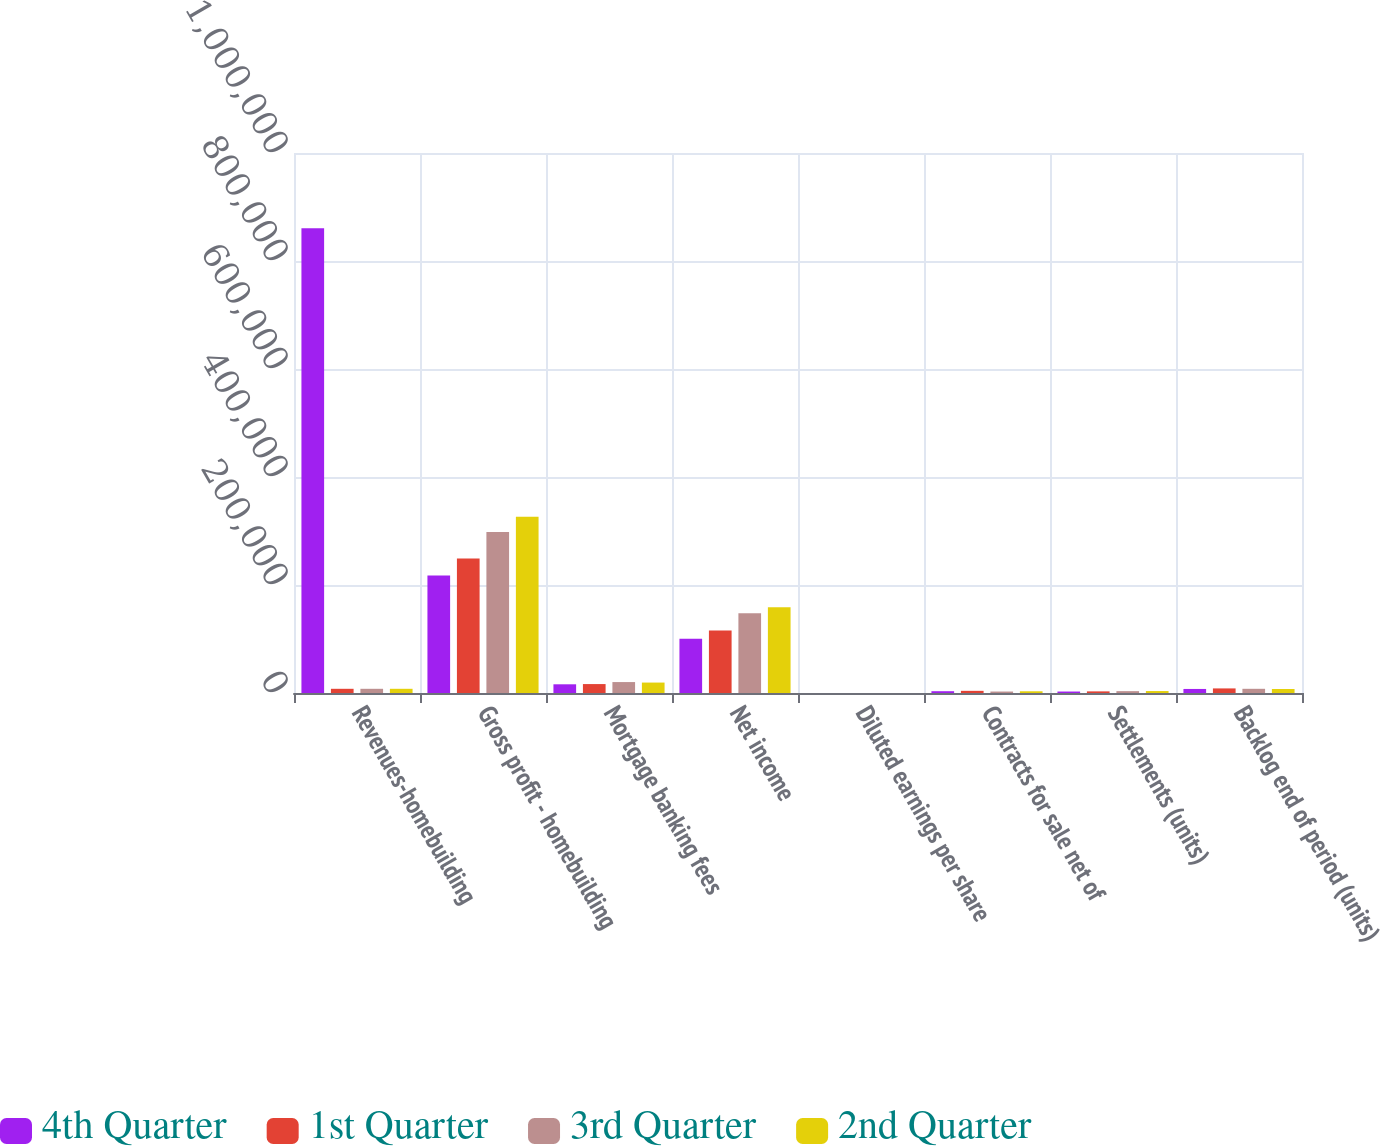Convert chart. <chart><loc_0><loc_0><loc_500><loc_500><stacked_bar_chart><ecel><fcel>Revenues-homebuilding<fcel>Gross profit - homebuilding<fcel>Mortgage banking fees<fcel>Net income<fcel>Diluted earnings per share<fcel>Contracts for sale net of<fcel>Settlements (units)<fcel>Backlog end of period (units)<nl><fcel>4th Quarter<fcel>860685<fcel>217674<fcel>16108<fcel>100617<fcel>12.58<fcel>3318<fcel>2709<fcel>7499<nl><fcel>1st Quarter<fcel>7775<fcel>248855<fcel>16543<fcel>115970<fcel>14.82<fcel>4001<fcel>3010<fcel>8490<nl><fcel>3rd Quarter<fcel>7775<fcel>298076<fcel>20248<fcel>147679<fcel>19.04<fcel>2718<fcel>3433<fcel>7775<nl><fcel>2nd Quarter<fcel>7775<fcel>326612<fcel>19320<fcel>158938<fcel>20.13<fcel>3194<fcel>3597<fcel>7372<nl></chart> 